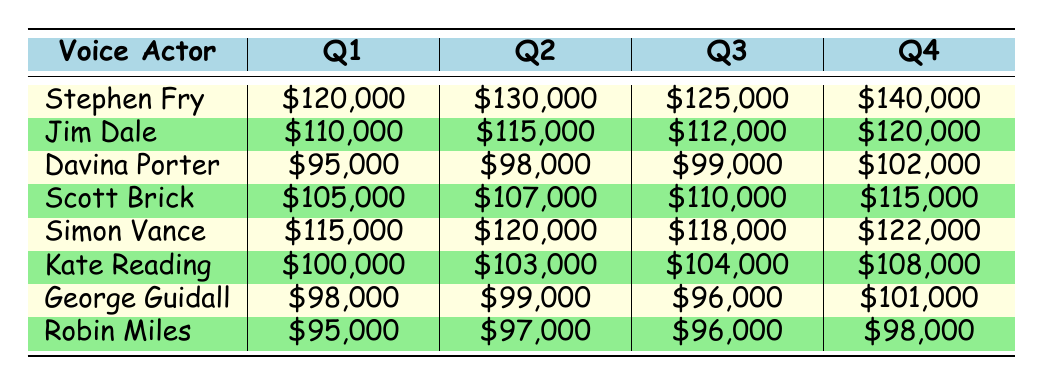What were Stephen Fry's earnings in Q4? Stephen Fry's earnings in Q4 are directly listed in the table. I can find that his earnings are \$140,000.
Answer: \$140,000 Who earned the least in Q1? I can look at the Q1 earnings of all voice actors. Davina Porter earned \$95,000, which is the lowest compared to others.
Answer: Davina Porter What is the total earnings of Jim Dale across all quarters? To find Jim Dale's total earnings, I add his earnings from each quarter: \$110,000 + \$115,000 + \$112,000 + \$120,000 = \$457,000.
Answer: \$457,000 Did George Guidall's earnings increase every quarter? I can compare George Guidall's earnings in each quarter: Q1 \$98,000, Q2 \$99,000, Q3 \$96,000, Q4 \$101,000. Since Q3 is lower than Q2, his earnings did not increase every quarter.
Answer: No What is the average earnings of Kate Reading for the year? To calculate the average, I add her earnings: \$100,000 + \$103,000 + \$104,000 + \$108,000 = \$415,000. Then divide by 4 (the number of quarters): \$415,000 / 4 = \$103,750.
Answer: \$103,750 Which voice actor had the highest total earnings for the year? I need to sum the earnings for each voice actor and compare them. Stephen Fry's total is \$505,000, Jim Dale's is \$457,000, Davina Porter's is \$392,000, Scott Brick's is \$437,000, Simon Vance's is \$475,000, Kate Reading's is \$415,000, George Guidall’s is \$394,000, and Robin Miles' is \$391,000. Stephen Fry has the highest total earnings.
Answer: Stephen Fry How much more did Simon Vance earn in Q4 compared to Q1? I look at Simon Vance's earnings for Q4, which are \$122,000, and for Q1, they are \$115,000. The difference is \$122,000 - \$115,000 = \$7,000.
Answer: \$7,000 Was Davina Porter’s Q3 earning higher than Scott Brick's Q1 earning? I can check Davina Porter's Q3 earnings, which are \$99,000, and Scott Brick's Q1 earnings, which are \$105,000. Since \$99,000 is less than \$105,000, her earnings were not higher.
Answer: No 